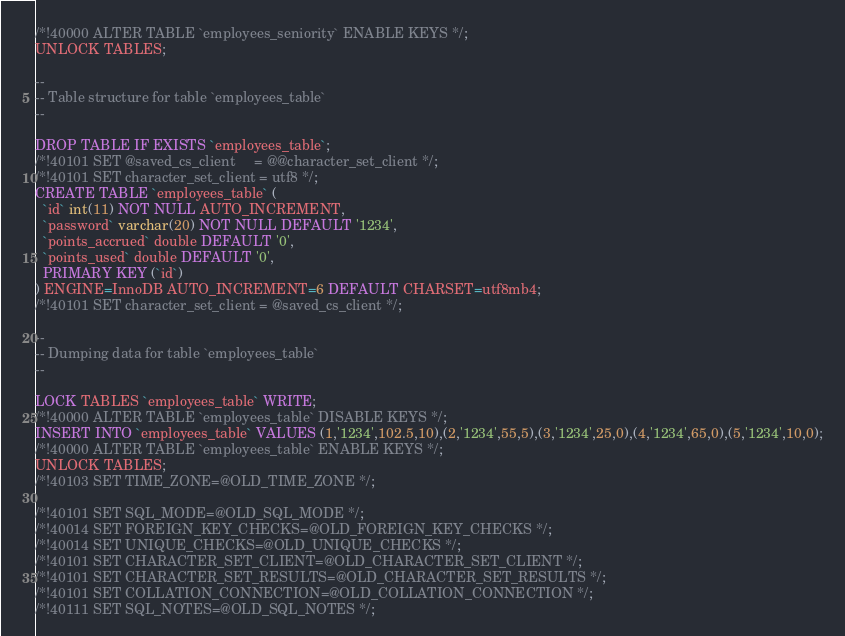<code> <loc_0><loc_0><loc_500><loc_500><_SQL_>/*!40000 ALTER TABLE `employees_seniority` ENABLE KEYS */;
UNLOCK TABLES;

--
-- Table structure for table `employees_table`
--

DROP TABLE IF EXISTS `employees_table`;
/*!40101 SET @saved_cs_client     = @@character_set_client */;
/*!40101 SET character_set_client = utf8 */;
CREATE TABLE `employees_table` (
  `id` int(11) NOT NULL AUTO_INCREMENT,
  `password` varchar(20) NOT NULL DEFAULT '1234',
  `points_accrued` double DEFAULT '0',
  `points_used` double DEFAULT '0',
  PRIMARY KEY (`id`)
) ENGINE=InnoDB AUTO_INCREMENT=6 DEFAULT CHARSET=utf8mb4;
/*!40101 SET character_set_client = @saved_cs_client */;

--
-- Dumping data for table `employees_table`
--

LOCK TABLES `employees_table` WRITE;
/*!40000 ALTER TABLE `employees_table` DISABLE KEYS */;
INSERT INTO `employees_table` VALUES (1,'1234',102.5,10),(2,'1234',55,5),(3,'1234',25,0),(4,'1234',65,0),(5,'1234',10,0);
/*!40000 ALTER TABLE `employees_table` ENABLE KEYS */;
UNLOCK TABLES;
/*!40103 SET TIME_ZONE=@OLD_TIME_ZONE */;

/*!40101 SET SQL_MODE=@OLD_SQL_MODE */;
/*!40014 SET FOREIGN_KEY_CHECKS=@OLD_FOREIGN_KEY_CHECKS */;
/*!40014 SET UNIQUE_CHECKS=@OLD_UNIQUE_CHECKS */;
/*!40101 SET CHARACTER_SET_CLIENT=@OLD_CHARACTER_SET_CLIENT */;
/*!40101 SET CHARACTER_SET_RESULTS=@OLD_CHARACTER_SET_RESULTS */;
/*!40101 SET COLLATION_CONNECTION=@OLD_COLLATION_CONNECTION */;
/*!40111 SET SQL_NOTES=@OLD_SQL_NOTES */;
</code> 